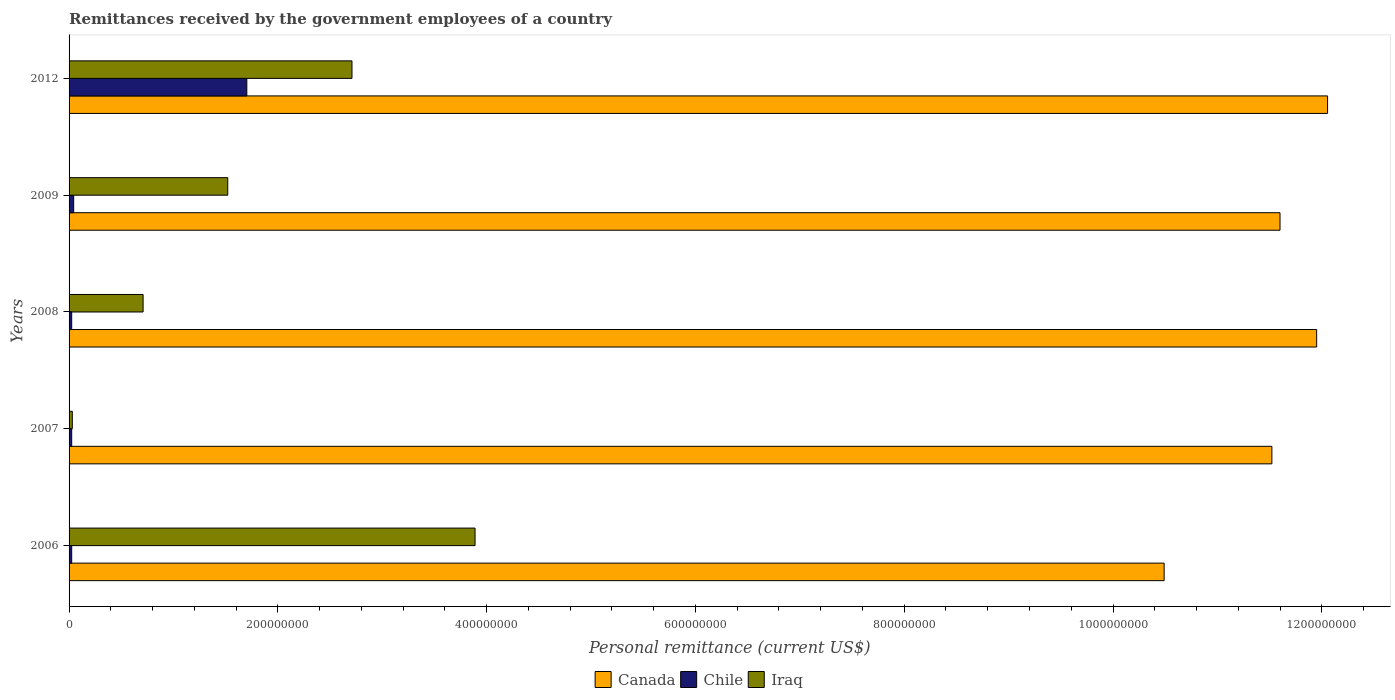How many different coloured bars are there?
Offer a very short reply. 3. How many groups of bars are there?
Offer a very short reply. 5. Are the number of bars per tick equal to the number of legend labels?
Provide a short and direct response. Yes. How many bars are there on the 1st tick from the top?
Your answer should be compact. 3. How many bars are there on the 5th tick from the bottom?
Offer a very short reply. 3. What is the label of the 2nd group of bars from the top?
Provide a succinct answer. 2009. In how many cases, is the number of bars for a given year not equal to the number of legend labels?
Make the answer very short. 0. What is the remittances received by the government employees in Iraq in 2008?
Provide a succinct answer. 7.09e+07. Across all years, what is the maximum remittances received by the government employees in Canada?
Your answer should be very brief. 1.21e+09. Across all years, what is the minimum remittances received by the government employees in Chile?
Keep it short and to the point. 2.50e+06. In which year was the remittances received by the government employees in Chile maximum?
Provide a succinct answer. 2012. What is the total remittances received by the government employees in Chile in the graph?
Ensure brevity in your answer.  1.82e+08. What is the difference between the remittances received by the government employees in Iraq in 2007 and that in 2012?
Make the answer very short. -2.68e+08. What is the difference between the remittances received by the government employees in Iraq in 2008 and the remittances received by the government employees in Chile in 2007?
Give a very brief answer. 6.84e+07. What is the average remittances received by the government employees in Chile per year?
Offer a very short reply. 3.64e+07. In the year 2006, what is the difference between the remittances received by the government employees in Iraq and remittances received by the government employees in Chile?
Give a very brief answer. 3.86e+08. What is the ratio of the remittances received by the government employees in Canada in 2006 to that in 2009?
Offer a very short reply. 0.9. Is the remittances received by the government employees in Iraq in 2006 less than that in 2009?
Offer a terse response. No. What is the difference between the highest and the second highest remittances received by the government employees in Chile?
Your answer should be very brief. 1.66e+08. What is the difference between the highest and the lowest remittances received by the government employees in Iraq?
Make the answer very short. 3.86e+08. Is the sum of the remittances received by the government employees in Canada in 2006 and 2008 greater than the maximum remittances received by the government employees in Chile across all years?
Ensure brevity in your answer.  Yes. What does the 3rd bar from the top in 2006 represents?
Provide a succinct answer. Canada. What does the 1st bar from the bottom in 2012 represents?
Your answer should be compact. Canada. Are all the bars in the graph horizontal?
Ensure brevity in your answer.  Yes. What is the difference between two consecutive major ticks on the X-axis?
Provide a succinct answer. 2.00e+08. Are the values on the major ticks of X-axis written in scientific E-notation?
Your response must be concise. No. Does the graph contain any zero values?
Your answer should be very brief. No. Where does the legend appear in the graph?
Keep it short and to the point. Bottom center. What is the title of the graph?
Provide a short and direct response. Remittances received by the government employees of a country. What is the label or title of the X-axis?
Offer a terse response. Personal remittance (current US$). What is the Personal remittance (current US$) of Canada in 2006?
Keep it short and to the point. 1.05e+09. What is the Personal remittance (current US$) of Chile in 2006?
Provide a succinct answer. 2.50e+06. What is the Personal remittance (current US$) in Iraq in 2006?
Give a very brief answer. 3.89e+08. What is the Personal remittance (current US$) in Canada in 2007?
Give a very brief answer. 1.15e+09. What is the Personal remittance (current US$) in Chile in 2007?
Offer a very short reply. 2.50e+06. What is the Personal remittance (current US$) in Iraq in 2007?
Offer a terse response. 3.10e+06. What is the Personal remittance (current US$) of Canada in 2008?
Your answer should be very brief. 1.20e+09. What is the Personal remittance (current US$) of Chile in 2008?
Offer a very short reply. 2.50e+06. What is the Personal remittance (current US$) in Iraq in 2008?
Your answer should be very brief. 7.09e+07. What is the Personal remittance (current US$) of Canada in 2009?
Your response must be concise. 1.16e+09. What is the Personal remittance (current US$) in Chile in 2009?
Your answer should be very brief. 4.40e+06. What is the Personal remittance (current US$) in Iraq in 2009?
Provide a succinct answer. 1.52e+08. What is the Personal remittance (current US$) in Canada in 2012?
Make the answer very short. 1.21e+09. What is the Personal remittance (current US$) of Chile in 2012?
Give a very brief answer. 1.70e+08. What is the Personal remittance (current US$) in Iraq in 2012?
Your response must be concise. 2.71e+08. Across all years, what is the maximum Personal remittance (current US$) in Canada?
Make the answer very short. 1.21e+09. Across all years, what is the maximum Personal remittance (current US$) of Chile?
Ensure brevity in your answer.  1.70e+08. Across all years, what is the maximum Personal remittance (current US$) of Iraq?
Ensure brevity in your answer.  3.89e+08. Across all years, what is the minimum Personal remittance (current US$) of Canada?
Your answer should be very brief. 1.05e+09. Across all years, what is the minimum Personal remittance (current US$) in Chile?
Your answer should be very brief. 2.50e+06. Across all years, what is the minimum Personal remittance (current US$) in Iraq?
Provide a short and direct response. 3.10e+06. What is the total Personal remittance (current US$) of Canada in the graph?
Provide a succinct answer. 5.76e+09. What is the total Personal remittance (current US$) of Chile in the graph?
Provide a succinct answer. 1.82e+08. What is the total Personal remittance (current US$) of Iraq in the graph?
Make the answer very short. 8.86e+08. What is the difference between the Personal remittance (current US$) in Canada in 2006 and that in 2007?
Provide a succinct answer. -1.03e+08. What is the difference between the Personal remittance (current US$) of Chile in 2006 and that in 2007?
Offer a terse response. 0. What is the difference between the Personal remittance (current US$) of Iraq in 2006 and that in 2007?
Your answer should be compact. 3.86e+08. What is the difference between the Personal remittance (current US$) in Canada in 2006 and that in 2008?
Keep it short and to the point. -1.46e+08. What is the difference between the Personal remittance (current US$) of Iraq in 2006 and that in 2008?
Your response must be concise. 3.18e+08. What is the difference between the Personal remittance (current US$) of Canada in 2006 and that in 2009?
Provide a short and direct response. -1.11e+08. What is the difference between the Personal remittance (current US$) in Chile in 2006 and that in 2009?
Give a very brief answer. -1.90e+06. What is the difference between the Personal remittance (current US$) in Iraq in 2006 and that in 2009?
Make the answer very short. 2.37e+08. What is the difference between the Personal remittance (current US$) in Canada in 2006 and that in 2012?
Offer a terse response. -1.57e+08. What is the difference between the Personal remittance (current US$) in Chile in 2006 and that in 2012?
Ensure brevity in your answer.  -1.68e+08. What is the difference between the Personal remittance (current US$) of Iraq in 2006 and that in 2012?
Provide a succinct answer. 1.18e+08. What is the difference between the Personal remittance (current US$) in Canada in 2007 and that in 2008?
Ensure brevity in your answer.  -4.29e+07. What is the difference between the Personal remittance (current US$) in Chile in 2007 and that in 2008?
Provide a succinct answer. 0. What is the difference between the Personal remittance (current US$) in Iraq in 2007 and that in 2008?
Make the answer very short. -6.78e+07. What is the difference between the Personal remittance (current US$) of Canada in 2007 and that in 2009?
Ensure brevity in your answer.  -7.80e+06. What is the difference between the Personal remittance (current US$) in Chile in 2007 and that in 2009?
Keep it short and to the point. -1.90e+06. What is the difference between the Personal remittance (current US$) in Iraq in 2007 and that in 2009?
Ensure brevity in your answer.  -1.49e+08. What is the difference between the Personal remittance (current US$) of Canada in 2007 and that in 2012?
Your response must be concise. -5.33e+07. What is the difference between the Personal remittance (current US$) in Chile in 2007 and that in 2012?
Offer a terse response. -1.68e+08. What is the difference between the Personal remittance (current US$) in Iraq in 2007 and that in 2012?
Give a very brief answer. -2.68e+08. What is the difference between the Personal remittance (current US$) in Canada in 2008 and that in 2009?
Your response must be concise. 3.51e+07. What is the difference between the Personal remittance (current US$) in Chile in 2008 and that in 2009?
Offer a very short reply. -1.90e+06. What is the difference between the Personal remittance (current US$) of Iraq in 2008 and that in 2009?
Your answer should be very brief. -8.11e+07. What is the difference between the Personal remittance (current US$) of Canada in 2008 and that in 2012?
Your answer should be compact. -1.04e+07. What is the difference between the Personal remittance (current US$) of Chile in 2008 and that in 2012?
Keep it short and to the point. -1.68e+08. What is the difference between the Personal remittance (current US$) in Iraq in 2008 and that in 2012?
Keep it short and to the point. -2.00e+08. What is the difference between the Personal remittance (current US$) in Canada in 2009 and that in 2012?
Your answer should be very brief. -4.56e+07. What is the difference between the Personal remittance (current US$) in Chile in 2009 and that in 2012?
Provide a short and direct response. -1.66e+08. What is the difference between the Personal remittance (current US$) in Iraq in 2009 and that in 2012?
Provide a succinct answer. -1.19e+08. What is the difference between the Personal remittance (current US$) in Canada in 2006 and the Personal remittance (current US$) in Chile in 2007?
Your answer should be very brief. 1.05e+09. What is the difference between the Personal remittance (current US$) in Canada in 2006 and the Personal remittance (current US$) in Iraq in 2007?
Offer a very short reply. 1.05e+09. What is the difference between the Personal remittance (current US$) in Chile in 2006 and the Personal remittance (current US$) in Iraq in 2007?
Your answer should be very brief. -6.00e+05. What is the difference between the Personal remittance (current US$) of Canada in 2006 and the Personal remittance (current US$) of Chile in 2008?
Your answer should be compact. 1.05e+09. What is the difference between the Personal remittance (current US$) of Canada in 2006 and the Personal remittance (current US$) of Iraq in 2008?
Ensure brevity in your answer.  9.78e+08. What is the difference between the Personal remittance (current US$) of Chile in 2006 and the Personal remittance (current US$) of Iraq in 2008?
Your response must be concise. -6.84e+07. What is the difference between the Personal remittance (current US$) in Canada in 2006 and the Personal remittance (current US$) in Chile in 2009?
Your response must be concise. 1.04e+09. What is the difference between the Personal remittance (current US$) of Canada in 2006 and the Personal remittance (current US$) of Iraq in 2009?
Your response must be concise. 8.97e+08. What is the difference between the Personal remittance (current US$) in Chile in 2006 and the Personal remittance (current US$) in Iraq in 2009?
Make the answer very short. -1.50e+08. What is the difference between the Personal remittance (current US$) in Canada in 2006 and the Personal remittance (current US$) in Chile in 2012?
Keep it short and to the point. 8.79e+08. What is the difference between the Personal remittance (current US$) in Canada in 2006 and the Personal remittance (current US$) in Iraq in 2012?
Provide a succinct answer. 7.78e+08. What is the difference between the Personal remittance (current US$) of Chile in 2006 and the Personal remittance (current US$) of Iraq in 2012?
Ensure brevity in your answer.  -2.68e+08. What is the difference between the Personal remittance (current US$) in Canada in 2007 and the Personal remittance (current US$) in Chile in 2008?
Offer a very short reply. 1.15e+09. What is the difference between the Personal remittance (current US$) in Canada in 2007 and the Personal remittance (current US$) in Iraq in 2008?
Give a very brief answer. 1.08e+09. What is the difference between the Personal remittance (current US$) in Chile in 2007 and the Personal remittance (current US$) in Iraq in 2008?
Your answer should be very brief. -6.84e+07. What is the difference between the Personal remittance (current US$) of Canada in 2007 and the Personal remittance (current US$) of Chile in 2009?
Make the answer very short. 1.15e+09. What is the difference between the Personal remittance (current US$) in Canada in 2007 and the Personal remittance (current US$) in Iraq in 2009?
Your response must be concise. 1.00e+09. What is the difference between the Personal remittance (current US$) of Chile in 2007 and the Personal remittance (current US$) of Iraq in 2009?
Your answer should be very brief. -1.50e+08. What is the difference between the Personal remittance (current US$) in Canada in 2007 and the Personal remittance (current US$) in Chile in 2012?
Provide a succinct answer. 9.82e+08. What is the difference between the Personal remittance (current US$) in Canada in 2007 and the Personal remittance (current US$) in Iraq in 2012?
Your answer should be compact. 8.81e+08. What is the difference between the Personal remittance (current US$) of Chile in 2007 and the Personal remittance (current US$) of Iraq in 2012?
Ensure brevity in your answer.  -2.68e+08. What is the difference between the Personal remittance (current US$) of Canada in 2008 and the Personal remittance (current US$) of Chile in 2009?
Ensure brevity in your answer.  1.19e+09. What is the difference between the Personal remittance (current US$) of Canada in 2008 and the Personal remittance (current US$) of Iraq in 2009?
Offer a very short reply. 1.04e+09. What is the difference between the Personal remittance (current US$) in Chile in 2008 and the Personal remittance (current US$) in Iraq in 2009?
Provide a short and direct response. -1.50e+08. What is the difference between the Personal remittance (current US$) in Canada in 2008 and the Personal remittance (current US$) in Chile in 2012?
Keep it short and to the point. 1.02e+09. What is the difference between the Personal remittance (current US$) in Canada in 2008 and the Personal remittance (current US$) in Iraq in 2012?
Your answer should be compact. 9.24e+08. What is the difference between the Personal remittance (current US$) of Chile in 2008 and the Personal remittance (current US$) of Iraq in 2012?
Provide a short and direct response. -2.68e+08. What is the difference between the Personal remittance (current US$) of Canada in 2009 and the Personal remittance (current US$) of Chile in 2012?
Offer a terse response. 9.90e+08. What is the difference between the Personal remittance (current US$) of Canada in 2009 and the Personal remittance (current US$) of Iraq in 2012?
Provide a short and direct response. 8.89e+08. What is the difference between the Personal remittance (current US$) in Chile in 2009 and the Personal remittance (current US$) in Iraq in 2012?
Offer a very short reply. -2.67e+08. What is the average Personal remittance (current US$) in Canada per year?
Offer a terse response. 1.15e+09. What is the average Personal remittance (current US$) in Chile per year?
Your answer should be compact. 3.64e+07. What is the average Personal remittance (current US$) in Iraq per year?
Provide a succinct answer. 1.77e+08. In the year 2006, what is the difference between the Personal remittance (current US$) of Canada and Personal remittance (current US$) of Chile?
Provide a short and direct response. 1.05e+09. In the year 2006, what is the difference between the Personal remittance (current US$) of Canada and Personal remittance (current US$) of Iraq?
Offer a terse response. 6.60e+08. In the year 2006, what is the difference between the Personal remittance (current US$) of Chile and Personal remittance (current US$) of Iraq?
Offer a very short reply. -3.86e+08. In the year 2007, what is the difference between the Personal remittance (current US$) in Canada and Personal remittance (current US$) in Chile?
Keep it short and to the point. 1.15e+09. In the year 2007, what is the difference between the Personal remittance (current US$) of Canada and Personal remittance (current US$) of Iraq?
Provide a succinct answer. 1.15e+09. In the year 2007, what is the difference between the Personal remittance (current US$) of Chile and Personal remittance (current US$) of Iraq?
Give a very brief answer. -6.00e+05. In the year 2008, what is the difference between the Personal remittance (current US$) in Canada and Personal remittance (current US$) in Chile?
Offer a very short reply. 1.19e+09. In the year 2008, what is the difference between the Personal remittance (current US$) in Canada and Personal remittance (current US$) in Iraq?
Your response must be concise. 1.12e+09. In the year 2008, what is the difference between the Personal remittance (current US$) of Chile and Personal remittance (current US$) of Iraq?
Provide a short and direct response. -6.84e+07. In the year 2009, what is the difference between the Personal remittance (current US$) in Canada and Personal remittance (current US$) in Chile?
Ensure brevity in your answer.  1.16e+09. In the year 2009, what is the difference between the Personal remittance (current US$) in Canada and Personal remittance (current US$) in Iraq?
Offer a very short reply. 1.01e+09. In the year 2009, what is the difference between the Personal remittance (current US$) of Chile and Personal remittance (current US$) of Iraq?
Your response must be concise. -1.48e+08. In the year 2012, what is the difference between the Personal remittance (current US$) in Canada and Personal remittance (current US$) in Chile?
Offer a very short reply. 1.04e+09. In the year 2012, what is the difference between the Personal remittance (current US$) of Canada and Personal remittance (current US$) of Iraq?
Ensure brevity in your answer.  9.35e+08. In the year 2012, what is the difference between the Personal remittance (current US$) of Chile and Personal remittance (current US$) of Iraq?
Your answer should be compact. -1.01e+08. What is the ratio of the Personal remittance (current US$) in Canada in 2006 to that in 2007?
Offer a terse response. 0.91. What is the ratio of the Personal remittance (current US$) of Chile in 2006 to that in 2007?
Keep it short and to the point. 1. What is the ratio of the Personal remittance (current US$) of Iraq in 2006 to that in 2007?
Offer a terse response. 125.45. What is the ratio of the Personal remittance (current US$) of Canada in 2006 to that in 2008?
Ensure brevity in your answer.  0.88. What is the ratio of the Personal remittance (current US$) in Chile in 2006 to that in 2008?
Your response must be concise. 1. What is the ratio of the Personal remittance (current US$) of Iraq in 2006 to that in 2008?
Your answer should be compact. 5.49. What is the ratio of the Personal remittance (current US$) in Canada in 2006 to that in 2009?
Make the answer very short. 0.9. What is the ratio of the Personal remittance (current US$) of Chile in 2006 to that in 2009?
Provide a succinct answer. 0.57. What is the ratio of the Personal remittance (current US$) of Iraq in 2006 to that in 2009?
Offer a very short reply. 2.56. What is the ratio of the Personal remittance (current US$) of Canada in 2006 to that in 2012?
Offer a terse response. 0.87. What is the ratio of the Personal remittance (current US$) in Chile in 2006 to that in 2012?
Your answer should be compact. 0.01. What is the ratio of the Personal remittance (current US$) of Iraq in 2006 to that in 2012?
Keep it short and to the point. 1.44. What is the ratio of the Personal remittance (current US$) in Canada in 2007 to that in 2008?
Give a very brief answer. 0.96. What is the ratio of the Personal remittance (current US$) in Chile in 2007 to that in 2008?
Give a very brief answer. 1. What is the ratio of the Personal remittance (current US$) in Iraq in 2007 to that in 2008?
Your answer should be very brief. 0.04. What is the ratio of the Personal remittance (current US$) in Chile in 2007 to that in 2009?
Ensure brevity in your answer.  0.57. What is the ratio of the Personal remittance (current US$) in Iraq in 2007 to that in 2009?
Make the answer very short. 0.02. What is the ratio of the Personal remittance (current US$) in Canada in 2007 to that in 2012?
Make the answer very short. 0.96. What is the ratio of the Personal remittance (current US$) of Chile in 2007 to that in 2012?
Keep it short and to the point. 0.01. What is the ratio of the Personal remittance (current US$) of Iraq in 2007 to that in 2012?
Offer a very short reply. 0.01. What is the ratio of the Personal remittance (current US$) in Canada in 2008 to that in 2009?
Provide a succinct answer. 1.03. What is the ratio of the Personal remittance (current US$) in Chile in 2008 to that in 2009?
Your answer should be very brief. 0.57. What is the ratio of the Personal remittance (current US$) of Iraq in 2008 to that in 2009?
Provide a succinct answer. 0.47. What is the ratio of the Personal remittance (current US$) in Canada in 2008 to that in 2012?
Ensure brevity in your answer.  0.99. What is the ratio of the Personal remittance (current US$) in Chile in 2008 to that in 2012?
Give a very brief answer. 0.01. What is the ratio of the Personal remittance (current US$) of Iraq in 2008 to that in 2012?
Offer a terse response. 0.26. What is the ratio of the Personal remittance (current US$) in Canada in 2009 to that in 2012?
Provide a short and direct response. 0.96. What is the ratio of the Personal remittance (current US$) in Chile in 2009 to that in 2012?
Your response must be concise. 0.03. What is the ratio of the Personal remittance (current US$) of Iraq in 2009 to that in 2012?
Your answer should be compact. 0.56. What is the difference between the highest and the second highest Personal remittance (current US$) in Canada?
Keep it short and to the point. 1.04e+07. What is the difference between the highest and the second highest Personal remittance (current US$) of Chile?
Give a very brief answer. 1.66e+08. What is the difference between the highest and the second highest Personal remittance (current US$) of Iraq?
Provide a succinct answer. 1.18e+08. What is the difference between the highest and the lowest Personal remittance (current US$) in Canada?
Provide a short and direct response. 1.57e+08. What is the difference between the highest and the lowest Personal remittance (current US$) of Chile?
Offer a very short reply. 1.68e+08. What is the difference between the highest and the lowest Personal remittance (current US$) in Iraq?
Provide a succinct answer. 3.86e+08. 